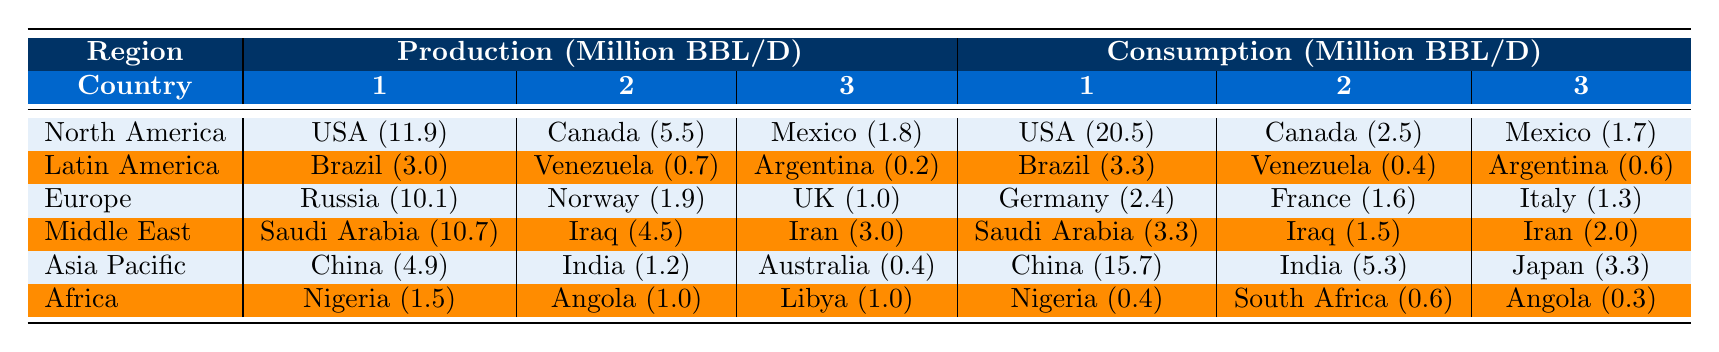What's the total oil production in North America? The production values for North America are 11.9 million BBL/D (USA), 5.5 million BBL/D (Canada), and 1.8 million BBL/D (Mexico). Adding these gives 11.9 + 5.5 + 1.8 = 19.2 million BBL/D.
Answer: 19.2 million BBL/D Which country in Eurasia has the highest oil production? In Europe, Russia is listed with a production of 10.1 million BBL/D, which is higher than Norway (1.9) and the UK (1.0).
Answer: Russia What is the total oil consumption of Latin America? The consumption values for Latin America are 3.3 million BBL/D (Brazil), 0.4 million BBL/D (Venezuela), and 0.6 million BBL/D (Argentina). Adding these gives 3.3 + 0.4 + 0.6 = 4.3 million BBL/D.
Answer: 4.3 million BBL/D Does Canada consume more oil than Mexico? Canada consumes 2.5 million BBL/D and Mexico consumes 1.7 million BBL/D. Since 2.5 > 1.7, Canada consumes more oil than Mexico.
Answer: Yes What is the average oil production of the Middle Eastern countries listed? The production values are 10.7 million BBL/D (Saudi Arabia), 4.5 million BBL/D (Iraq), and 3.0 million BBL/D (Iran). Summing these gives 10.7 + 4.5 + 3.0 = 18.2 million BBL/D. The average is 18.2 / 3 ≈ 6.07 million BBL/D.
Answer: Approximately 6.07 million BBL/D Which region has the highest total oil consumption? The total consumption for each region is calculated as follows: North America: 24.7 million BBL/D; Latin America: 4.3 million BBL/D; Europe: 5.3 million BBL/D; Middle East: 6.8 million BBL/D; Asia Pacific: 24.3 million BBL/D; Africa: 1.3 million BBL/D. North America has the highest total at 24.7 million BBL/D.
Answer: North America Is the oil production in Asia Pacific greater than that in Africa? The total production in Asia Pacific is 6.5 million BBL/D (China, India, Australia) while in Africa, it is 3.5 million BBL/D (Nigeria, Angola, Libya). Since 6.5 > 3.5, Asia Pacific has greater production.
Answer: Yes What is the total oil consumption of the countries listed in Europe? The European consumption values are 2.4 million BBL/D (Germany), 1.6 million BBL/D (France), and 1.3 million BBL/D (Italy). Adding these gives 2.4 + 1.6 + 1.3 = 5.3 million BBL/D.
Answer: 5.3 million BBL/D Which region produces the least oil? The lowest production values are from Africa with 3.5 million BBL/D (Nigeria, Angola, Libya), compared to other regions such as Latin America with 4.0 million BBL/D.
Answer: Africa What is the difference between the total oil consumption in North America and the Middle East? North America consumes 24.7 million BBL/D and the Middle East consumes 6.8 million BBL/D. The difference is 24.7 - 6.8 = 17.9 million BBL/D.
Answer: 17.9 million BBL/D 